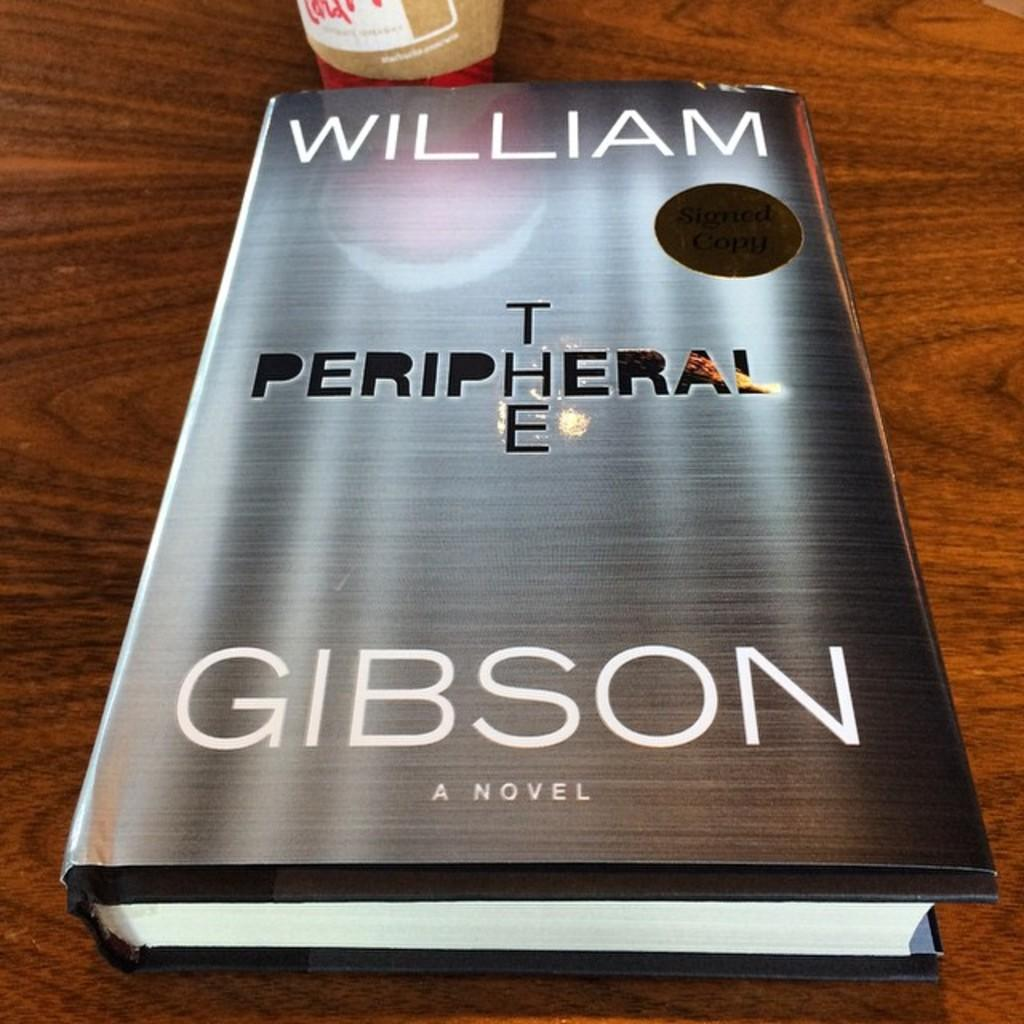Provide a one-sentence caption for the provided image. The book on the table is written by William Gibson. 